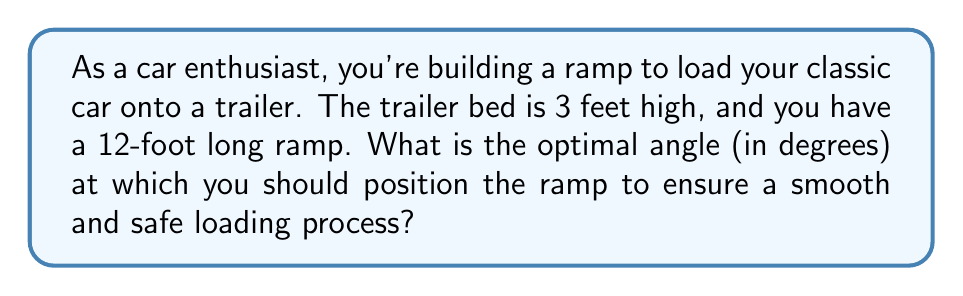What is the answer to this math problem? Let's approach this step-by-step using trigonometry:

1) First, we need to visualize the problem. We have a right triangle where:
   - The height (rise) is 3 feet (trailer bed height)
   - The hypotenuse is 12 feet (length of the ramp)
   - We need to find the angle between the ground and the ramp

2) In this right triangle, we know the opposite side (3 feet) and the hypotenuse (12 feet).

3) The trigonometric function that relates the opposite side to the hypotenuse is sine (sin).

4) We can set up the equation:

   $$\sin(\theta) = \frac{\text{opposite}}{\text{hypotenuse}} = \frac{3}{12} = \frac{1}{4}$$

5) To find the angle $\theta$, we need to take the inverse sine (arcsin or $\sin^{-1}$) of both sides:

   $$\theta = \sin^{-1}(\frac{1}{4})$$

6) Using a calculator or trigonometric tables, we can solve this:

   $$\theta \approx 14.4775\text{ degrees}$$

7) Rounding to the nearest tenth of a degree for practical purposes:

   $$\theta \approx 14.5\text{ degrees}$$

This angle provides a good balance between ease of loading (not too steep) and efficient use of space (not too gradual).

[asy]
import geometry;

size(200);

pair A=(0,0), B=(12,0), C=(0,3);
draw(A--B--C--A);
draw(rightanglemark(A,B,C,20));

label("3 ft",C--A,W);
label("12 ft",A--B,S);
label("$\theta$",angle(C,A,B),SE);

pair D = (11,0);
draw(arc(D,0.5,0,14.5),Arrow);
label("14.5°",(11.7,0.3),E);
[/asy]
Answer: 14.5° 